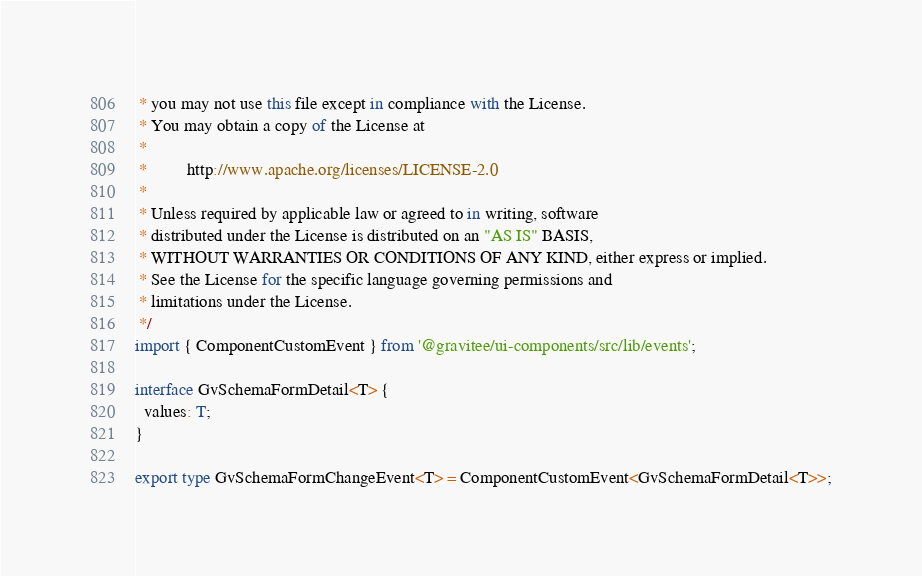Convert code to text. <code><loc_0><loc_0><loc_500><loc_500><_TypeScript_> * you may not use this file except in compliance with the License.
 * You may obtain a copy of the License at
 *
 *         http://www.apache.org/licenses/LICENSE-2.0
 *
 * Unless required by applicable law or agreed to in writing, software
 * distributed under the License is distributed on an "AS IS" BASIS,
 * WITHOUT WARRANTIES OR CONDITIONS OF ANY KIND, either express or implied.
 * See the License for the specific language governing permissions and
 * limitations under the License.
 */
import { ComponentCustomEvent } from '@gravitee/ui-components/src/lib/events';

interface GvSchemaFormDetail<T> {
  values: T;
}

export type GvSchemaFormChangeEvent<T> = ComponentCustomEvent<GvSchemaFormDetail<T>>;
</code> 